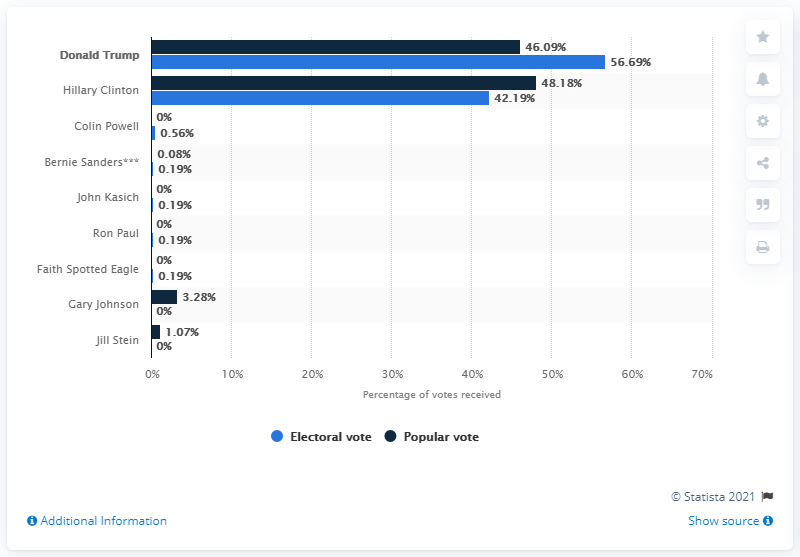Outline some significant characteristics in this image. Hillary Clinton became the first female candidate nominated by a major party for the presidency. 